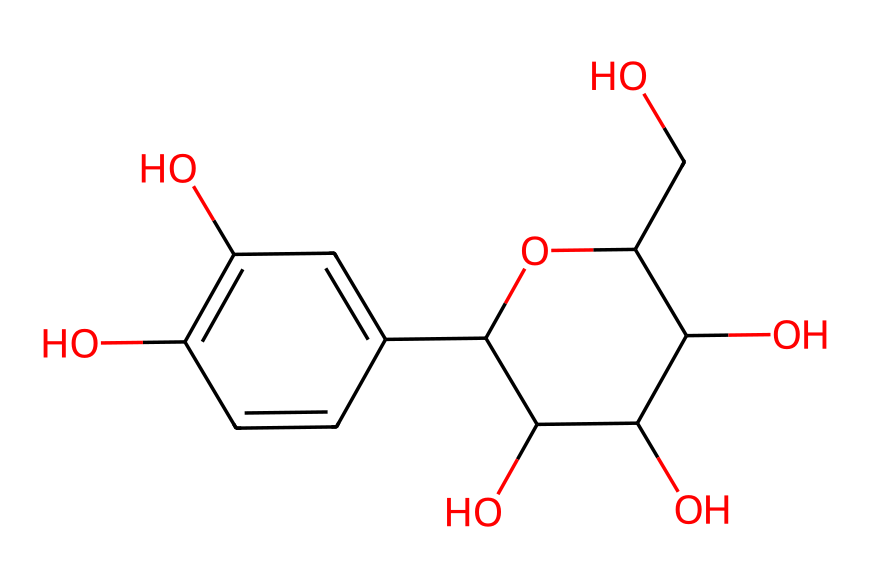what is the basic structure of this compound? The compound has a complex structure featuring multiple hydroxyl (-OH) groups and a fused ring system, indicative of a polyphenolic structure commonly found in herbal remedies.
Answer: polyphenolic structure how many carbon atoms are present in this chemical? By analyzing the SMILES representation, we count the number of 'C' characters which indicates each carbon atom; a total of 15 carbon atoms are observed.
Answer: 15 is this compound likely to be hydrophilic or hydrophobic? The presence of multiple hydroxyl groups suggests that this compound would have a strong affinity for water due to hydrogen bonding, indicating it is hydrophilic.
Answer: hydrophilic what functional groups are present in this compound? The chemical contains hydroxyl (-OH) groups as significant functional groups based on the structure, contributing to its reactivity and solubility.
Answer: hydroxyl groups does this compound resemble any common natural compounds? Given its polyphenolic structure and hydroxyl functionality, it bears resemblance to flavonoids and other natural phenols found in plants, commonly used in traditional remedies.
Answer: flavonoids 